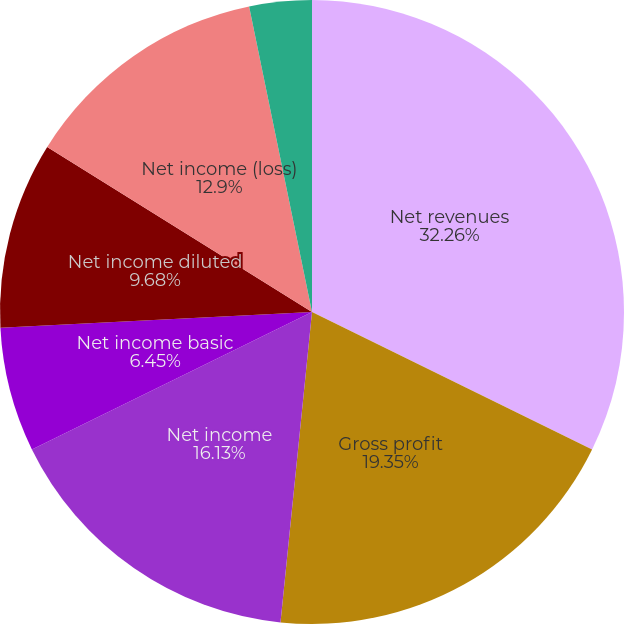Convert chart to OTSL. <chart><loc_0><loc_0><loc_500><loc_500><pie_chart><fcel>Net revenues<fcel>Gross profit<fcel>Net income<fcel>Net income basic<fcel>Net income diluted<fcel>Net income (loss)<fcel>Net income (loss) basic<fcel>Net income (loss) diluted<nl><fcel>32.26%<fcel>19.35%<fcel>16.13%<fcel>6.45%<fcel>9.68%<fcel>12.9%<fcel>0.0%<fcel>3.23%<nl></chart> 